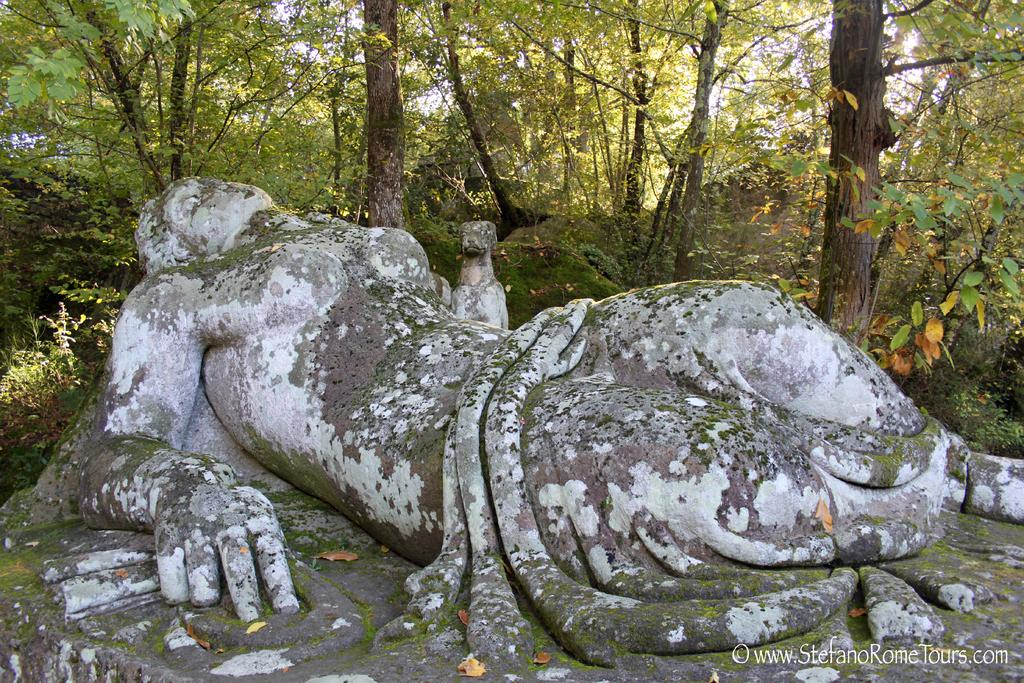What is the main subject in the center of the image? There is a sculpture in the center of the image. What can be seen in the background of the image? There are trees in the background of the image. What type of parcel is being crushed by the sculpture in the image? There is no parcel present in the image, and the sculpture is not crushing anything. 